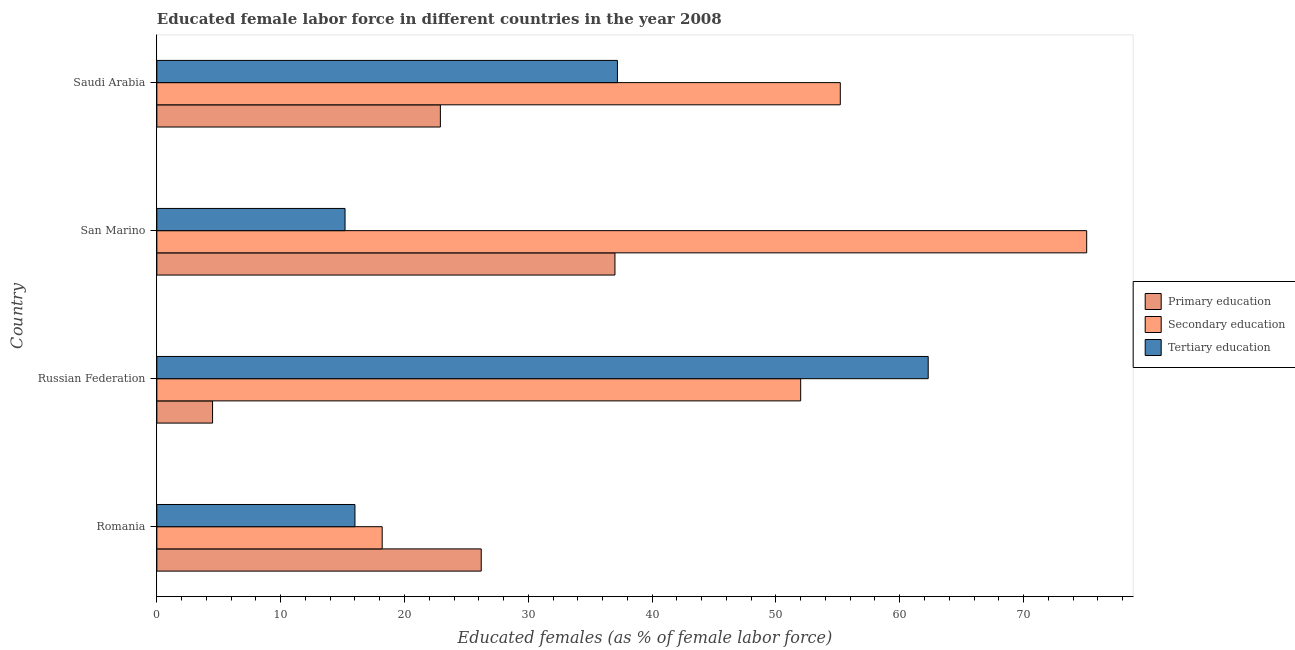Are the number of bars per tick equal to the number of legend labels?
Provide a succinct answer. Yes. Are the number of bars on each tick of the Y-axis equal?
Ensure brevity in your answer.  Yes. How many bars are there on the 4th tick from the bottom?
Make the answer very short. 3. What is the label of the 3rd group of bars from the top?
Your answer should be very brief. Russian Federation. In how many cases, is the number of bars for a given country not equal to the number of legend labels?
Keep it short and to the point. 0. What is the percentage of female labor force who received secondary education in Romania?
Ensure brevity in your answer.  18.2. Across all countries, what is the maximum percentage of female labor force who received tertiary education?
Give a very brief answer. 62.3. Across all countries, what is the minimum percentage of female labor force who received tertiary education?
Offer a very short reply. 15.2. In which country was the percentage of female labor force who received secondary education maximum?
Provide a succinct answer. San Marino. In which country was the percentage of female labor force who received primary education minimum?
Ensure brevity in your answer.  Russian Federation. What is the total percentage of female labor force who received secondary education in the graph?
Offer a very short reply. 200.5. What is the difference between the percentage of female labor force who received tertiary education in Russian Federation and that in San Marino?
Offer a very short reply. 47.1. What is the difference between the percentage of female labor force who received tertiary education in Russian Federation and the percentage of female labor force who received secondary education in San Marino?
Ensure brevity in your answer.  -12.8. What is the average percentage of female labor force who received tertiary education per country?
Give a very brief answer. 32.67. What is the difference between the percentage of female labor force who received tertiary education and percentage of female labor force who received primary education in Romania?
Your answer should be very brief. -10.2. What is the ratio of the percentage of female labor force who received primary education in Russian Federation to that in San Marino?
Provide a short and direct response. 0.12. Is the percentage of female labor force who received tertiary education in San Marino less than that in Saudi Arabia?
Make the answer very short. Yes. Is the difference between the percentage of female labor force who received secondary education in Romania and Russian Federation greater than the difference between the percentage of female labor force who received primary education in Romania and Russian Federation?
Make the answer very short. No. What is the difference between the highest and the lowest percentage of female labor force who received secondary education?
Offer a very short reply. 56.9. In how many countries, is the percentage of female labor force who received secondary education greater than the average percentage of female labor force who received secondary education taken over all countries?
Provide a short and direct response. 3. What does the 3rd bar from the top in Saudi Arabia represents?
Keep it short and to the point. Primary education. What does the 1st bar from the bottom in San Marino represents?
Provide a succinct answer. Primary education. How many bars are there?
Ensure brevity in your answer.  12. Are all the bars in the graph horizontal?
Keep it short and to the point. Yes. How many countries are there in the graph?
Offer a terse response. 4. What is the difference between two consecutive major ticks on the X-axis?
Your answer should be very brief. 10. Are the values on the major ticks of X-axis written in scientific E-notation?
Provide a succinct answer. No. Does the graph contain grids?
Your answer should be compact. No. How many legend labels are there?
Your answer should be very brief. 3. What is the title of the graph?
Make the answer very short. Educated female labor force in different countries in the year 2008. What is the label or title of the X-axis?
Your answer should be compact. Educated females (as % of female labor force). What is the label or title of the Y-axis?
Ensure brevity in your answer.  Country. What is the Educated females (as % of female labor force) of Primary education in Romania?
Keep it short and to the point. 26.2. What is the Educated females (as % of female labor force) in Secondary education in Romania?
Provide a short and direct response. 18.2. What is the Educated females (as % of female labor force) of Secondary education in Russian Federation?
Offer a terse response. 52. What is the Educated females (as % of female labor force) of Tertiary education in Russian Federation?
Your answer should be very brief. 62.3. What is the Educated females (as % of female labor force) of Primary education in San Marino?
Give a very brief answer. 37. What is the Educated females (as % of female labor force) of Secondary education in San Marino?
Provide a short and direct response. 75.1. What is the Educated females (as % of female labor force) of Tertiary education in San Marino?
Offer a very short reply. 15.2. What is the Educated females (as % of female labor force) in Primary education in Saudi Arabia?
Offer a terse response. 22.9. What is the Educated females (as % of female labor force) of Secondary education in Saudi Arabia?
Provide a succinct answer. 55.2. What is the Educated females (as % of female labor force) of Tertiary education in Saudi Arabia?
Your response must be concise. 37.2. Across all countries, what is the maximum Educated females (as % of female labor force) in Primary education?
Provide a short and direct response. 37. Across all countries, what is the maximum Educated females (as % of female labor force) of Secondary education?
Provide a short and direct response. 75.1. Across all countries, what is the maximum Educated females (as % of female labor force) in Tertiary education?
Provide a short and direct response. 62.3. Across all countries, what is the minimum Educated females (as % of female labor force) in Secondary education?
Your answer should be compact. 18.2. Across all countries, what is the minimum Educated females (as % of female labor force) of Tertiary education?
Make the answer very short. 15.2. What is the total Educated females (as % of female labor force) in Primary education in the graph?
Provide a succinct answer. 90.6. What is the total Educated females (as % of female labor force) in Secondary education in the graph?
Your answer should be very brief. 200.5. What is the total Educated females (as % of female labor force) of Tertiary education in the graph?
Your answer should be very brief. 130.7. What is the difference between the Educated females (as % of female labor force) in Primary education in Romania and that in Russian Federation?
Offer a terse response. 21.7. What is the difference between the Educated females (as % of female labor force) in Secondary education in Romania and that in Russian Federation?
Ensure brevity in your answer.  -33.8. What is the difference between the Educated females (as % of female labor force) of Tertiary education in Romania and that in Russian Federation?
Your response must be concise. -46.3. What is the difference between the Educated females (as % of female labor force) in Primary education in Romania and that in San Marino?
Offer a very short reply. -10.8. What is the difference between the Educated females (as % of female labor force) of Secondary education in Romania and that in San Marino?
Offer a very short reply. -56.9. What is the difference between the Educated females (as % of female labor force) of Tertiary education in Romania and that in San Marino?
Your response must be concise. 0.8. What is the difference between the Educated females (as % of female labor force) in Secondary education in Romania and that in Saudi Arabia?
Keep it short and to the point. -37. What is the difference between the Educated females (as % of female labor force) in Tertiary education in Romania and that in Saudi Arabia?
Keep it short and to the point. -21.2. What is the difference between the Educated females (as % of female labor force) of Primary education in Russian Federation and that in San Marino?
Your answer should be very brief. -32.5. What is the difference between the Educated females (as % of female labor force) in Secondary education in Russian Federation and that in San Marino?
Give a very brief answer. -23.1. What is the difference between the Educated females (as % of female labor force) in Tertiary education in Russian Federation and that in San Marino?
Provide a short and direct response. 47.1. What is the difference between the Educated females (as % of female labor force) of Primary education in Russian Federation and that in Saudi Arabia?
Offer a terse response. -18.4. What is the difference between the Educated females (as % of female labor force) of Secondary education in Russian Federation and that in Saudi Arabia?
Offer a terse response. -3.2. What is the difference between the Educated females (as % of female labor force) of Tertiary education in Russian Federation and that in Saudi Arabia?
Keep it short and to the point. 25.1. What is the difference between the Educated females (as % of female labor force) in Primary education in San Marino and that in Saudi Arabia?
Offer a very short reply. 14.1. What is the difference between the Educated females (as % of female labor force) of Secondary education in San Marino and that in Saudi Arabia?
Your answer should be very brief. 19.9. What is the difference between the Educated females (as % of female labor force) in Tertiary education in San Marino and that in Saudi Arabia?
Your answer should be very brief. -22. What is the difference between the Educated females (as % of female labor force) in Primary education in Romania and the Educated females (as % of female labor force) in Secondary education in Russian Federation?
Your answer should be very brief. -25.8. What is the difference between the Educated females (as % of female labor force) of Primary education in Romania and the Educated females (as % of female labor force) of Tertiary education in Russian Federation?
Your answer should be compact. -36.1. What is the difference between the Educated females (as % of female labor force) of Secondary education in Romania and the Educated females (as % of female labor force) of Tertiary education in Russian Federation?
Your answer should be very brief. -44.1. What is the difference between the Educated females (as % of female labor force) in Primary education in Romania and the Educated females (as % of female labor force) in Secondary education in San Marino?
Ensure brevity in your answer.  -48.9. What is the difference between the Educated females (as % of female labor force) of Secondary education in Romania and the Educated females (as % of female labor force) of Tertiary education in San Marino?
Your response must be concise. 3. What is the difference between the Educated females (as % of female labor force) of Secondary education in Romania and the Educated females (as % of female labor force) of Tertiary education in Saudi Arabia?
Your response must be concise. -19. What is the difference between the Educated females (as % of female labor force) of Primary education in Russian Federation and the Educated females (as % of female labor force) of Secondary education in San Marino?
Provide a succinct answer. -70.6. What is the difference between the Educated females (as % of female labor force) in Secondary education in Russian Federation and the Educated females (as % of female labor force) in Tertiary education in San Marino?
Your answer should be compact. 36.8. What is the difference between the Educated females (as % of female labor force) in Primary education in Russian Federation and the Educated females (as % of female labor force) in Secondary education in Saudi Arabia?
Keep it short and to the point. -50.7. What is the difference between the Educated females (as % of female labor force) in Primary education in Russian Federation and the Educated females (as % of female labor force) in Tertiary education in Saudi Arabia?
Offer a very short reply. -32.7. What is the difference between the Educated females (as % of female labor force) in Secondary education in Russian Federation and the Educated females (as % of female labor force) in Tertiary education in Saudi Arabia?
Your answer should be compact. 14.8. What is the difference between the Educated females (as % of female labor force) in Primary education in San Marino and the Educated females (as % of female labor force) in Secondary education in Saudi Arabia?
Provide a short and direct response. -18.2. What is the difference between the Educated females (as % of female labor force) in Secondary education in San Marino and the Educated females (as % of female labor force) in Tertiary education in Saudi Arabia?
Keep it short and to the point. 37.9. What is the average Educated females (as % of female labor force) in Primary education per country?
Keep it short and to the point. 22.65. What is the average Educated females (as % of female labor force) in Secondary education per country?
Your answer should be compact. 50.12. What is the average Educated females (as % of female labor force) of Tertiary education per country?
Keep it short and to the point. 32.67. What is the difference between the Educated females (as % of female labor force) in Primary education and Educated females (as % of female labor force) in Secondary education in Romania?
Your answer should be very brief. 8. What is the difference between the Educated females (as % of female labor force) in Primary education and Educated females (as % of female labor force) in Secondary education in Russian Federation?
Your response must be concise. -47.5. What is the difference between the Educated females (as % of female labor force) in Primary education and Educated females (as % of female labor force) in Tertiary education in Russian Federation?
Your answer should be compact. -57.8. What is the difference between the Educated females (as % of female labor force) of Secondary education and Educated females (as % of female labor force) of Tertiary education in Russian Federation?
Your response must be concise. -10.3. What is the difference between the Educated females (as % of female labor force) in Primary education and Educated females (as % of female labor force) in Secondary education in San Marino?
Give a very brief answer. -38.1. What is the difference between the Educated females (as % of female labor force) of Primary education and Educated females (as % of female labor force) of Tertiary education in San Marino?
Make the answer very short. 21.8. What is the difference between the Educated females (as % of female labor force) of Secondary education and Educated females (as % of female labor force) of Tertiary education in San Marino?
Keep it short and to the point. 59.9. What is the difference between the Educated females (as % of female labor force) in Primary education and Educated females (as % of female labor force) in Secondary education in Saudi Arabia?
Provide a succinct answer. -32.3. What is the difference between the Educated females (as % of female labor force) of Primary education and Educated females (as % of female labor force) of Tertiary education in Saudi Arabia?
Offer a terse response. -14.3. What is the difference between the Educated females (as % of female labor force) of Secondary education and Educated females (as % of female labor force) of Tertiary education in Saudi Arabia?
Make the answer very short. 18. What is the ratio of the Educated females (as % of female labor force) in Primary education in Romania to that in Russian Federation?
Ensure brevity in your answer.  5.82. What is the ratio of the Educated females (as % of female labor force) of Tertiary education in Romania to that in Russian Federation?
Ensure brevity in your answer.  0.26. What is the ratio of the Educated females (as % of female labor force) in Primary education in Romania to that in San Marino?
Make the answer very short. 0.71. What is the ratio of the Educated females (as % of female labor force) in Secondary education in Romania to that in San Marino?
Provide a succinct answer. 0.24. What is the ratio of the Educated females (as % of female labor force) in Tertiary education in Romania to that in San Marino?
Your response must be concise. 1.05. What is the ratio of the Educated females (as % of female labor force) of Primary education in Romania to that in Saudi Arabia?
Make the answer very short. 1.14. What is the ratio of the Educated females (as % of female labor force) of Secondary education in Romania to that in Saudi Arabia?
Keep it short and to the point. 0.33. What is the ratio of the Educated females (as % of female labor force) of Tertiary education in Romania to that in Saudi Arabia?
Keep it short and to the point. 0.43. What is the ratio of the Educated females (as % of female labor force) of Primary education in Russian Federation to that in San Marino?
Ensure brevity in your answer.  0.12. What is the ratio of the Educated females (as % of female labor force) in Secondary education in Russian Federation to that in San Marino?
Your answer should be compact. 0.69. What is the ratio of the Educated females (as % of female labor force) in Tertiary education in Russian Federation to that in San Marino?
Your answer should be compact. 4.1. What is the ratio of the Educated females (as % of female labor force) in Primary education in Russian Federation to that in Saudi Arabia?
Your answer should be very brief. 0.2. What is the ratio of the Educated females (as % of female labor force) in Secondary education in Russian Federation to that in Saudi Arabia?
Provide a short and direct response. 0.94. What is the ratio of the Educated females (as % of female labor force) of Tertiary education in Russian Federation to that in Saudi Arabia?
Ensure brevity in your answer.  1.67. What is the ratio of the Educated females (as % of female labor force) in Primary education in San Marino to that in Saudi Arabia?
Give a very brief answer. 1.62. What is the ratio of the Educated females (as % of female labor force) in Secondary education in San Marino to that in Saudi Arabia?
Offer a very short reply. 1.36. What is the ratio of the Educated females (as % of female labor force) of Tertiary education in San Marino to that in Saudi Arabia?
Keep it short and to the point. 0.41. What is the difference between the highest and the second highest Educated females (as % of female labor force) in Secondary education?
Your answer should be very brief. 19.9. What is the difference between the highest and the second highest Educated females (as % of female labor force) of Tertiary education?
Make the answer very short. 25.1. What is the difference between the highest and the lowest Educated females (as % of female labor force) of Primary education?
Give a very brief answer. 32.5. What is the difference between the highest and the lowest Educated females (as % of female labor force) in Secondary education?
Offer a very short reply. 56.9. What is the difference between the highest and the lowest Educated females (as % of female labor force) in Tertiary education?
Make the answer very short. 47.1. 